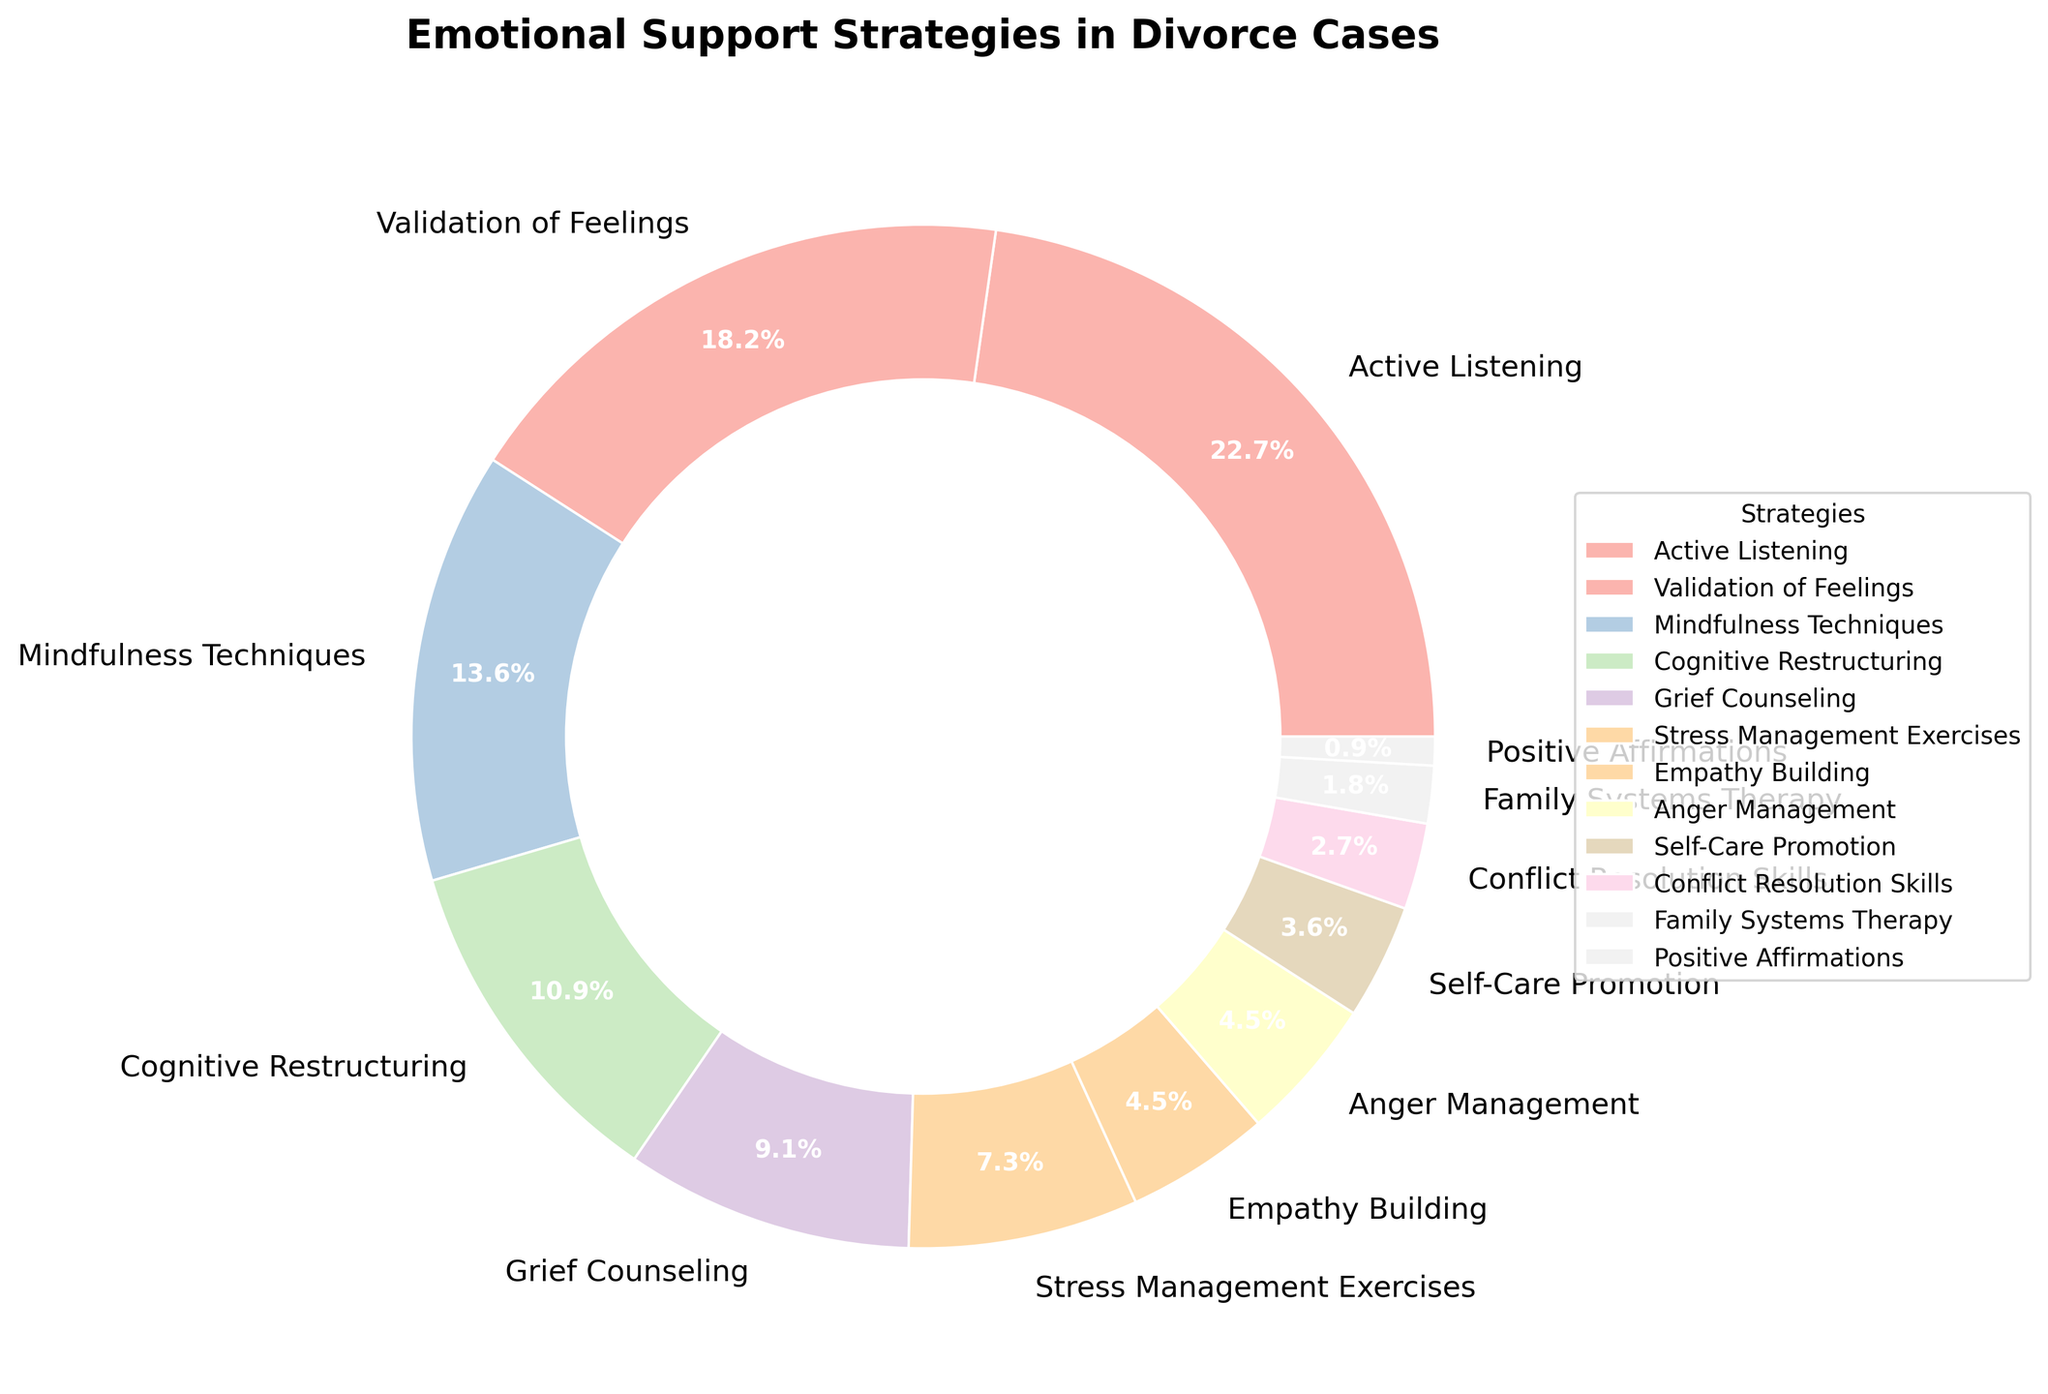What is the most commonly used emotional support strategy in divorce cases according to the pie chart? According to the pie chart, the most commonly used emotional support strategy is the one with the largest section. This section represents Active Listening, which accounts for 25% of the total.
Answer: Active Listening Which strategies combined make up at least 50% of the total? To determine this, add the percentages of the strategies starting from the highest until the total reaches or exceeds 50%. Active Listening is 25%, Validation of Feelings is 20%, and Mindfulness Techniques is 15%. 25% + 20% + 15% = 60%, which is more than 50%.
Answer: Active Listening, Validation of Feelings, Mindfulness Techniques Which strategy occupies a larger portion of the pie chart: Cognitive Restructuring or Stress Management Exercises? Look at the corresponding sections for Cognitive Restructuring and Stress Management Exercises. Cognitive Restructuring has 12%, while Stress Management Exercises has 8%. 12% is greater than 8%.
Answer: Cognitive Restructuring What is the combined percentage of Grief Counseling, Empathy Building, and Anger Management? Add the individual percentages for Grief Counseling, Empathy Building, and Anger Management. Grief Counseling is 10%, Empathy Building is 5%, and Anger Management is 5%. 10% + 5% + 5% = 20%.
Answer: 20% Which strategy is the least utilized according to the pie chart? The least utilized strategy will have the smallest percentage indicated in the pie chart. Positive Affirmations is shown as 1%, which is the smallest value.
Answer: Positive Affirmations By how much does Active Listening exceed Validation of Feelings? Subtract the percentage of Validation of Feelings from the percentage of Active Listening. Active Listening is 25%, and Validation of Feelings is 20%. 25% - 20% = 5%.
Answer: 5% Is the percentage for Family Systems Therapy greater than or less than half of that for Cognitive Restructuring? First, find half of the Cognitive Restructuring percentage: 12% / 2 = 6%. Then compare with Family Systems Therapy, which is 2%. 2% is less than 6%.
Answer: Less than What percentage of the strategies fall below 5% usage? Identify the strategies with percentages below 5%: Empathy Building (5%), Anger Management (5%), Self-Care Promotion (4%), Conflict Resolution Skills (3%), Family Systems Therapy (2%), and Positive Affirmations (1%). However, only strategies below 5% should be counted: Self-Care Promotion, Conflict Resolution Skills, Family Systems Therapy, Positive Affirmations. They add up to: 4% + 3% + 2% + 1% = 10%.
Answer: 10% How many strategies are used at a rate between 5% and 10%? Identify the strategies within this range: Empathy Building (5%), Anger Management (5%), and Stress Management Exercises (8%).
Answer: 3 What is the total percentage for the top three emotional support strategies? Sum the percentages of the top three strategies: Active Listening (25%), Validation of Feelings (20%), and Mindfulness Techniques (15%). 25% + 20% + 15% = 60%.
Answer: 60% 